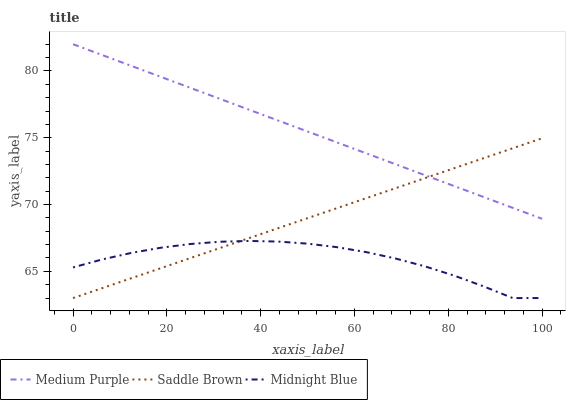Does Midnight Blue have the minimum area under the curve?
Answer yes or no. Yes. Does Medium Purple have the maximum area under the curve?
Answer yes or no. Yes. Does Saddle Brown have the minimum area under the curve?
Answer yes or no. No. Does Saddle Brown have the maximum area under the curve?
Answer yes or no. No. Is Saddle Brown the smoothest?
Answer yes or no. Yes. Is Midnight Blue the roughest?
Answer yes or no. Yes. Is Midnight Blue the smoothest?
Answer yes or no. No. Is Saddle Brown the roughest?
Answer yes or no. No. Does Saddle Brown have the lowest value?
Answer yes or no. Yes. Does Medium Purple have the highest value?
Answer yes or no. Yes. Does Saddle Brown have the highest value?
Answer yes or no. No. Is Midnight Blue less than Medium Purple?
Answer yes or no. Yes. Is Medium Purple greater than Midnight Blue?
Answer yes or no. Yes. Does Midnight Blue intersect Saddle Brown?
Answer yes or no. Yes. Is Midnight Blue less than Saddle Brown?
Answer yes or no. No. Is Midnight Blue greater than Saddle Brown?
Answer yes or no. No. Does Midnight Blue intersect Medium Purple?
Answer yes or no. No. 